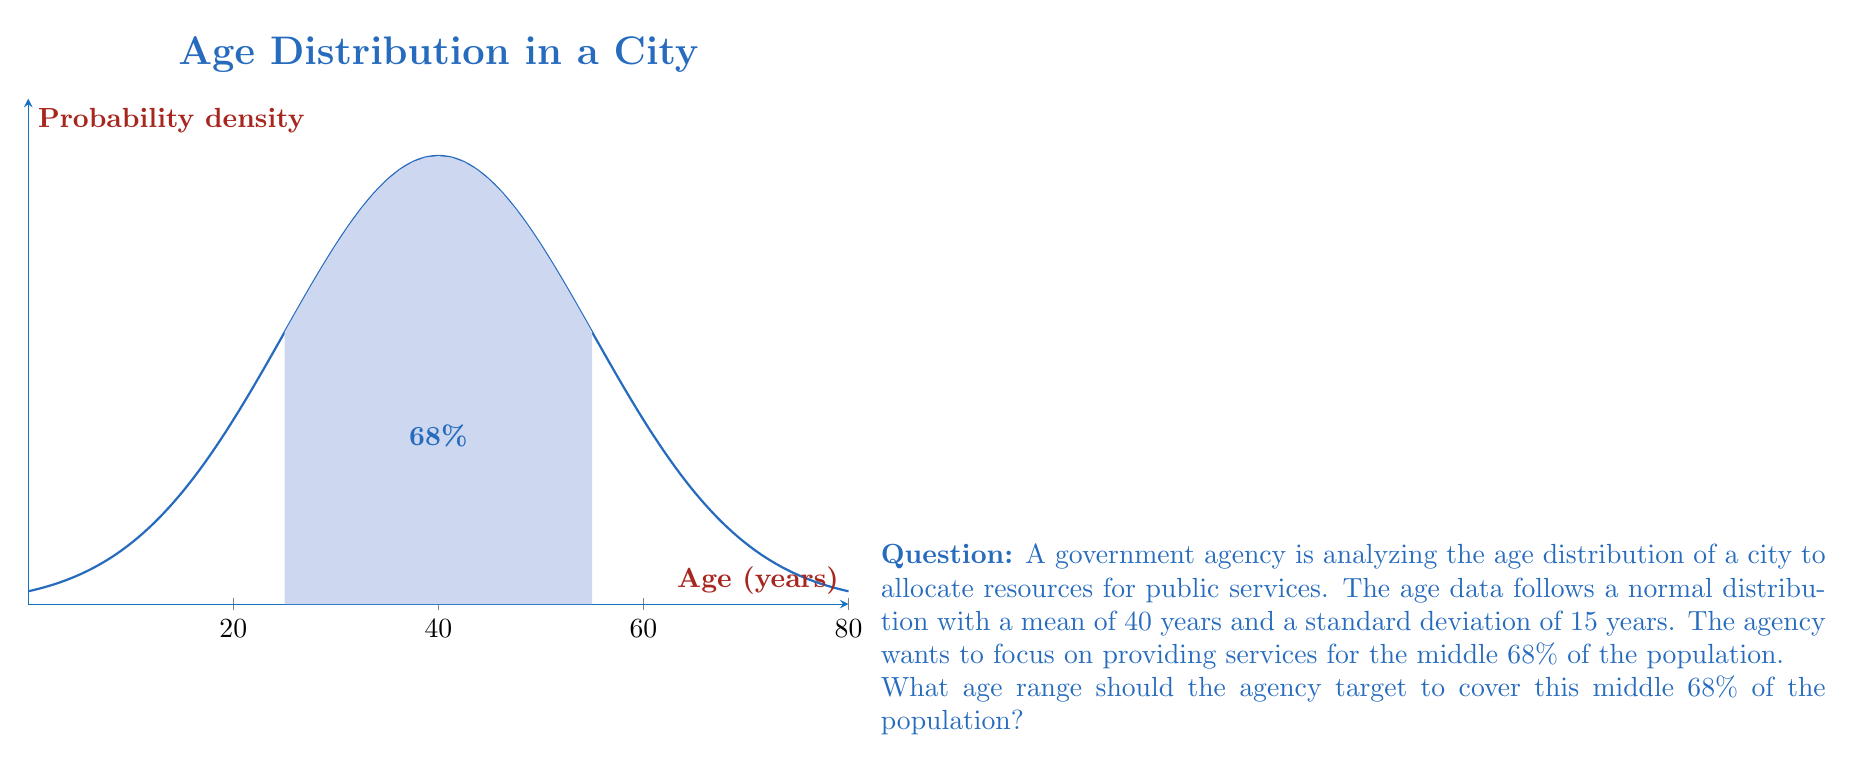Solve this math problem. To solve this problem, we need to use the properties of the normal distribution:

1) For a normal distribution, approximately 68% of the data falls within one standard deviation of the mean.

2) Given:
   - Mean (μ) = 40 years
   - Standard deviation (σ) = 15 years

3) To find the age range covering the middle 68% of the population:
   - Lower bound: μ - σ = 40 - 15 = 25 years
   - Upper bound: μ + σ = 40 + 15 = 55 years

4) We can verify this using the z-score formula:
   $$z = \frac{x - μ}{σ}$$

   For x = 25: $z = \frac{25 - 40}{15} = -1$
   For x = 55: $z = \frac{55 - 40}{15} = 1$

5) In a standard normal distribution, z-scores of -1 and 1 correspond to the 16th and 84th percentiles, respectively, covering the middle 68% of the data.

Therefore, the agency should target the age range of 25 to 55 years to cover the middle 68% of the population.
Answer: 25 to 55 years 